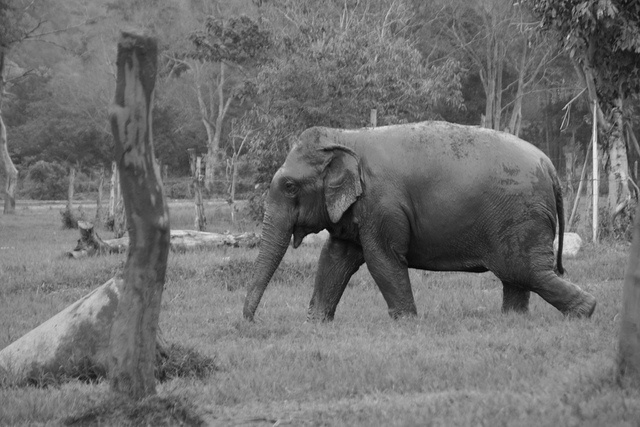Describe the objects in this image and their specific colors. I can see a elephant in gray, black, and lightgray tones in this image. 